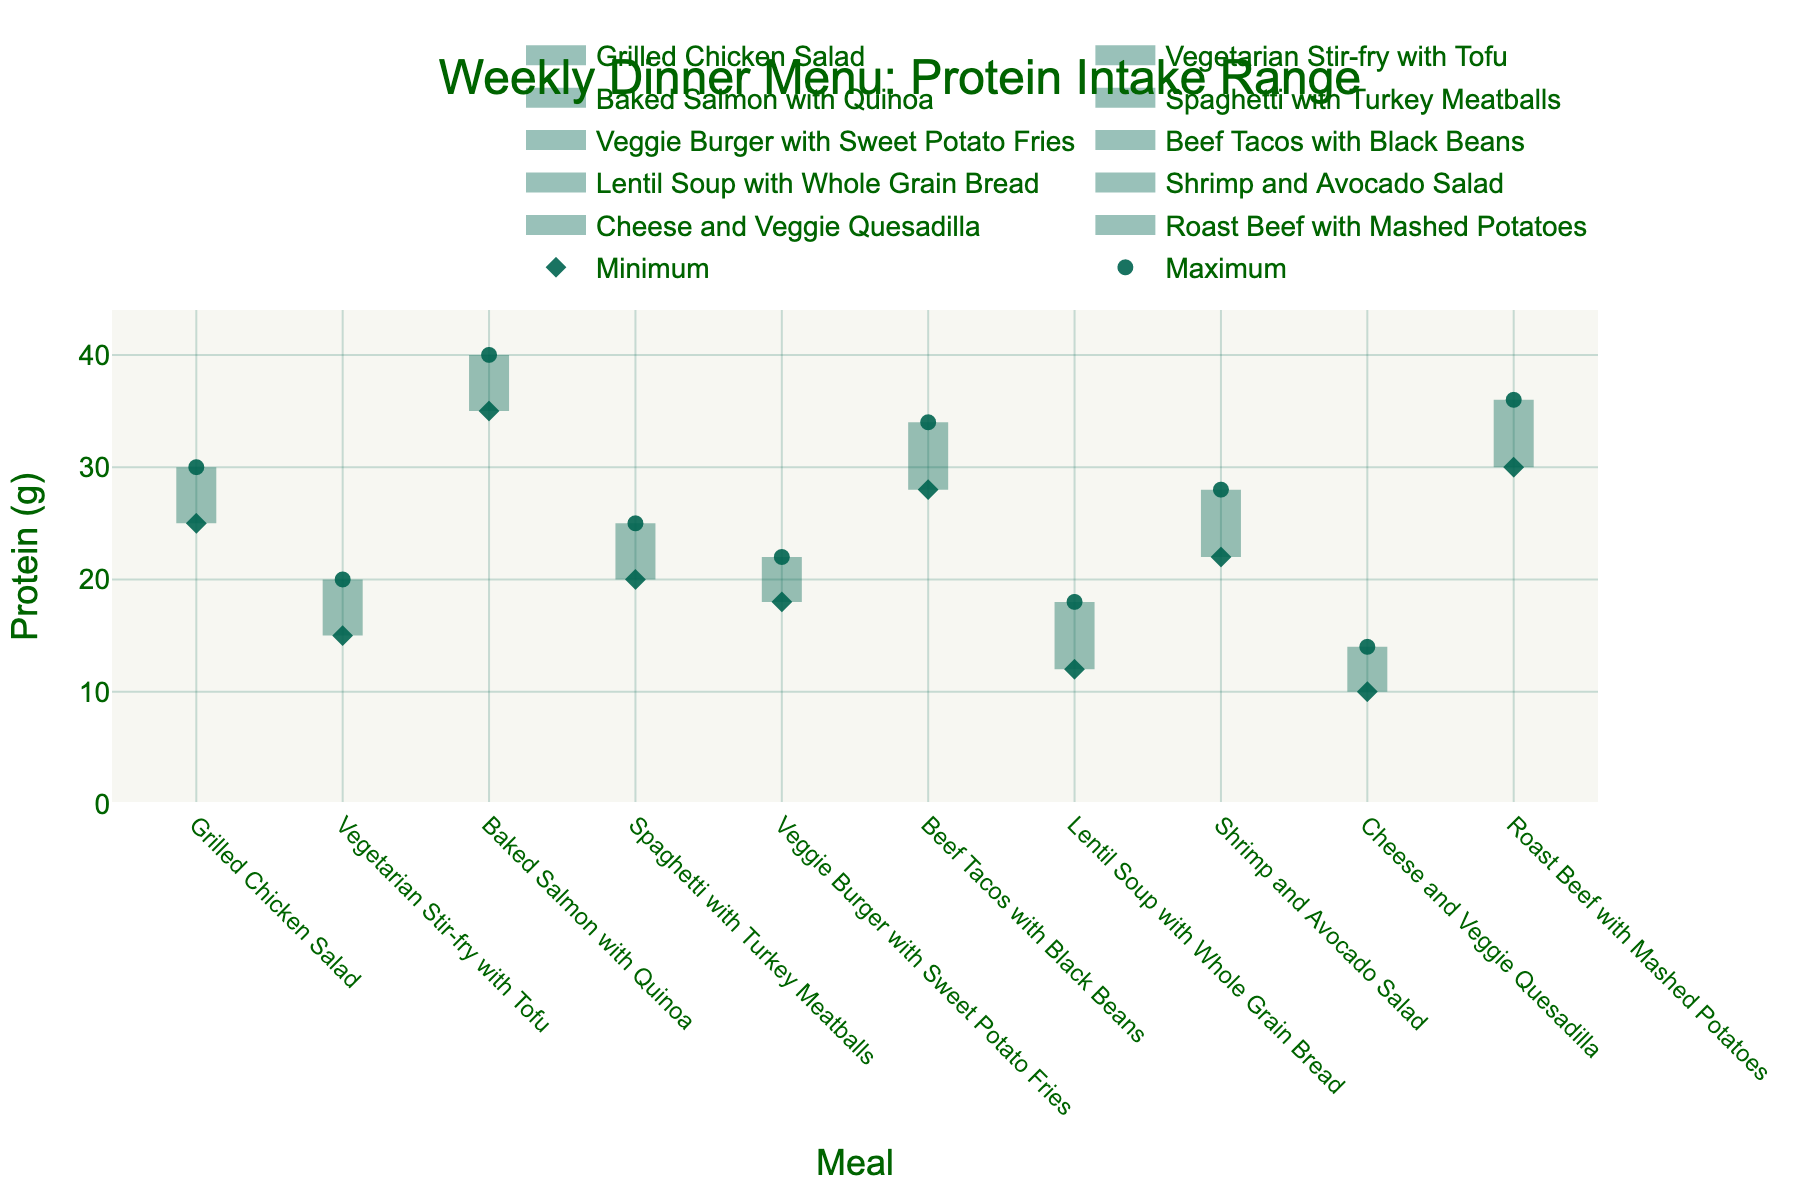what is the title of the figure? The title of the figure appears at the top of the chart, which summarizes the content visually and textually. It is focused on the protein intake across different meals for weekly dinner planning.
Answer: Weekly Dinner Menu: Protein Intake Range How many meals are included in the chart? You can count each distinct meal listed on the x-axis to determine the total number of data points represented.
Answer: 10 Which meal has the highest maximum protein intake? Look at the y-axis values and identify the meal that has the highest point on the plot.
Answer: Baked Salmon with Quinoa What is the protein intake range for Grilled Chicken Salad? Observe the two endpoints vertically aligned with "Grilled Chicken Salad" on the x-axis. The minimum and maximum y-axis values provide the range.
Answer: 25 to 30 grams How does the protein intake range for Vegetarian Stir-fry with Tofu compare to that of Veggie Burger with Sweet Potato Fries? Locate the two meals on the x-axis and compare their vertical endpoints on the y-axis to determine their protein intake range differences.
Answer: Vegetarian Stir-fry with Tofu: 15-20 grams, Veggie Burger with Sweet Potato Fries: 18-22 grams Which meal has the smallest range of protein intake? Determine the difference between the maximum and minimum protein intake values for each meal and identify the smallest one.
Answer: Cheese and Veggie Quesadilla Is there any vegetarian meal with a higher maximum protein intake than Shrimp and Avocado Salad? Identify the maximum protein intake values for vegetarian meals and compare them with the maximum for Shrimp and Avocado Salad.
Answer: No What is the average difference in protein intake ranges across all meals? Calculate the difference between maximum and minimum protein intake for each meal, then find the average across all meals. (28-10)/10 = 1.8
Answer: 1.8 grams Which meals have a minimum protein intake of 20 grams or higher? Look at the lower endpoints for each meal to identify which meals have their minimum protein intake at or above 20 grams.
Answer: Grilled Chicken Salad, Baked Salmon with Quinoa, Spaghetti with Turkey Meatballs, Beef Tacos with Black Beans, Roast Beef with Mashed Potatoes What is the total number of meals with a maximum protein intake of 30 grams or more? Count the meals for which the marker for maximum protein intake on the y-axis is 30 or higher.
Answer: 5 